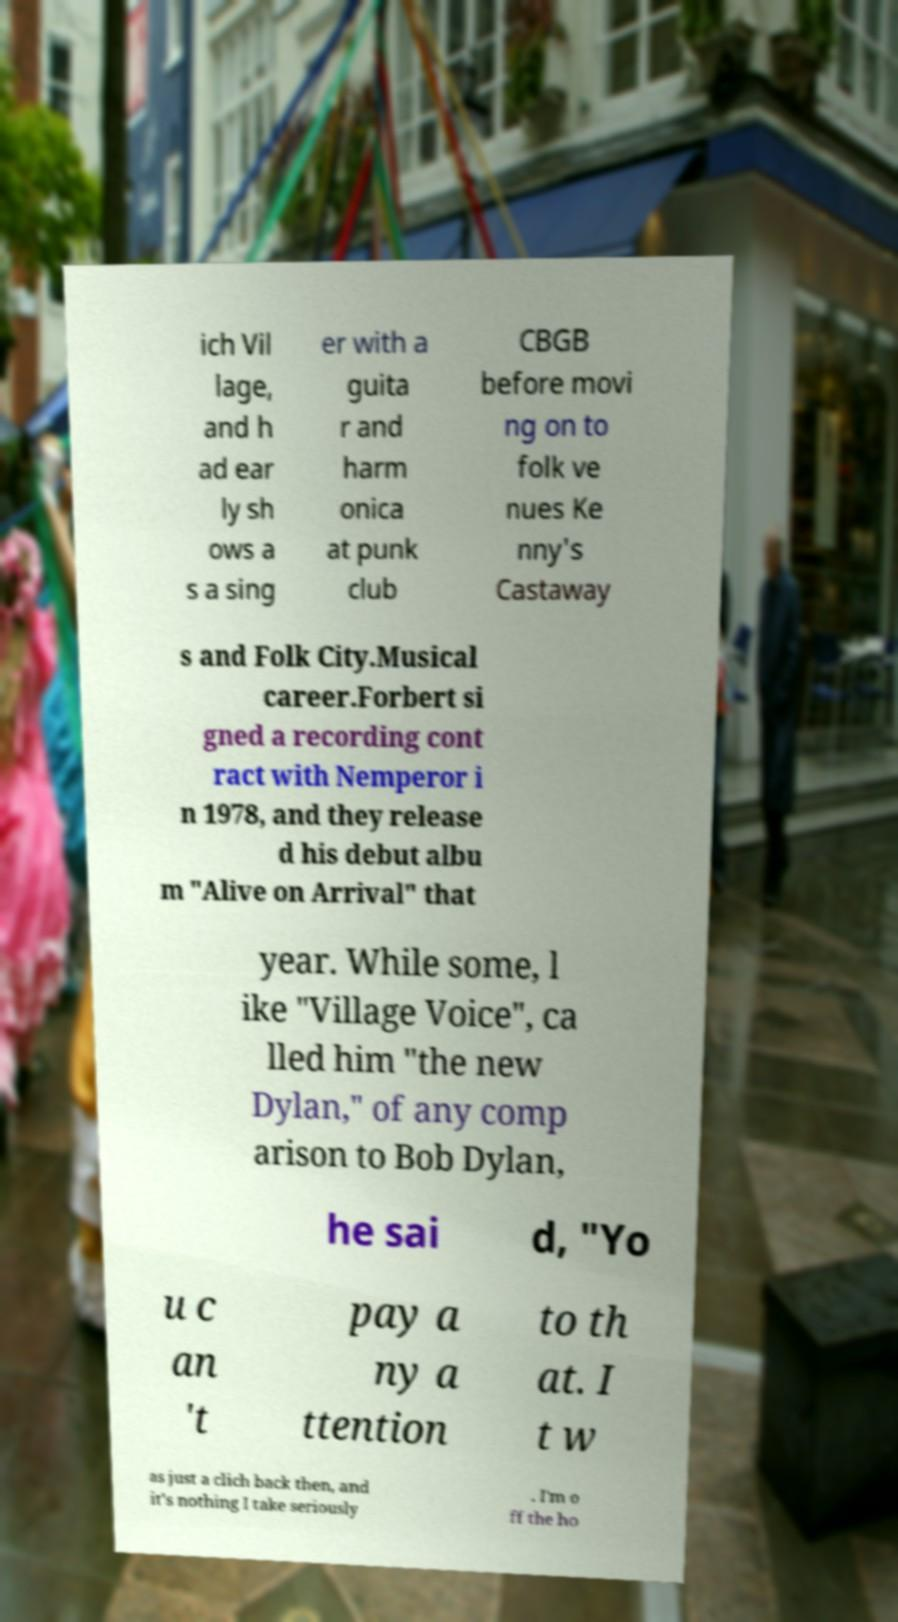Can you read and provide the text displayed in the image?This photo seems to have some interesting text. Can you extract and type it out for me? ich Vil lage, and h ad ear ly sh ows a s a sing er with a guita r and harm onica at punk club CBGB before movi ng on to folk ve nues Ke nny's Castaway s and Folk City.Musical career.Forbert si gned a recording cont ract with Nemperor i n 1978, and they release d his debut albu m "Alive on Arrival" that year. While some, l ike "Village Voice", ca lled him "the new Dylan," of any comp arison to Bob Dylan, he sai d, "Yo u c an 't pay a ny a ttention to th at. I t w as just a clich back then, and it's nothing I take seriously . I'm o ff the ho 